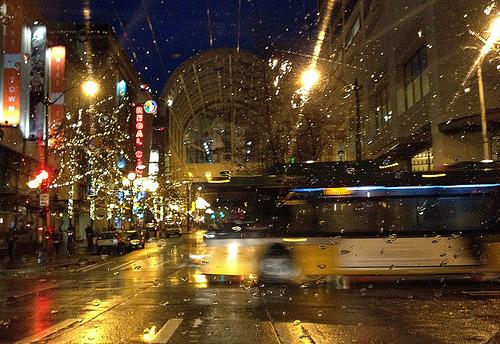Enumerate the objects that are illuminated in the image. Illuminated objects include street lights, lights on the trees, and red light from a traffic signal. Where are the people in the image? People are on the sidewalk, likely waiting for the bus or walking. Explain the impact of weather on this image's scene. The weather is rainy, resulting in wet pavement, raindrops on the windshield, and reflections from the red light. Determine the sentiment conveyed by the image. The image conveys a calm, yet busy sentiment during a rainy night in the city. What is the most visible vehicle in the image? A passenger bus on the street is the most visible vehicle. Provide a brief description of the overall scene in the image. The image shows a rainy night scene on a street with a bus, vehicles, people on the sidewalk, buildings with windows, and illuminated street lights. Identify the primary mode of transportation on the street in this image. The primary mode of transportation is a passenger bus on the road. How many types of signs or banners can you find in the image? There are 5 types: red and white signs, red neon light with letters, a banner hanging off the building, a street light sign, and a business name sign. What type(s) of road marking(s) can you see in the image? White painted lines can be seen on the ground. Describe the lighting situation in this image. The scene is lit by street lamps, yellow lights from the trees, and red light from a traffic signal. What color is the neon light with letters? Red Identify the colors of the light shown in the image. Yellow and red What is the main mode of public transportation depicted in the image? Bus What do the droplets on the image signify? Raindrops on the windshield What type of advertisement is hanging off the building? A business name sign What kind of scene is captured in the image? A night scene on a street Is there a group of people dancing on the sidewalk at X:49 Y:223 Width:48 Height:48? While there is mention of people on the sidewalk (X:49 Y:223 Width:48 Height:48), there is no information about them dancing. This instruction is misleading as it adds an attribute to the existing object that is not described. From the given expressions, determine which one best describes the people on the sidewalk. a) happy b) sad c) neutral c) neutral Is the bus floating in the air at X:450 Y:20 Width:242 Height:242? The bus is not floating in the air, it is on the road with its correct coordinates given as X:243 Y:176 Width:242 Height:242. Describe the motion of the bus in the image. The bus is in motion. What does the white line painted on the road signify? Lane divider What is the purpose of the street lamps in the image? To light the street at night Write a brief description of the image in a poem format. In the still of night's embrace, Which of the following is NOT seen in the image? a) bus b) street light c) airplanes c) airplanes Can you find a giant red ball at X:300 Y:50 Width:150 Height:150? No, it's not mentioned in the image. Create a catchy slogan based on the image. Travel through the rain on wheels of enchantment, board the night bus to a world unknown. Describe the position of the parked vehicles. Parked on the side of the street Describe the scene in an enchanting manner. A captivating night scene unfolds on a glistening rain-kissed street, where a bus gallops forward and street lamps cast an ethereal glow upon the bustling life below. State the condition of the pavement in the image. The pavement is wet. Infer and describe the position of the windows on the building. The windows are high up on the building. What does the red light in the image tell vehicles to do? Slow down What is the main focus of the image? A bus on the road during a rainy night Do you see a car driving upside down at X:93 Y:220 Width:58 Height:58? There are vehicles on the street at the mentioned coordinates, but there is no mention of any car driving upside down, so this instruction is misleading as it adds a false attribute to the existing object. Based on the details in the image, is it day or night? Night 